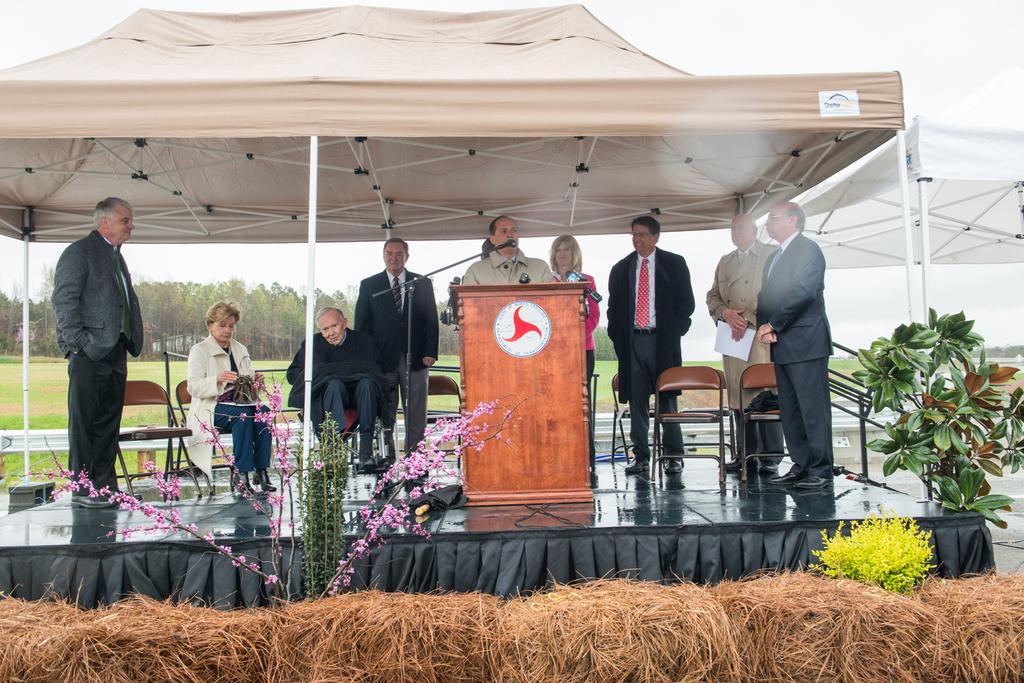In one or two sentences, can you explain what this image depicts? In this picture we can see plants, dried grass, tents, two people sitting on chairs and some people are standing on stage and a man standing at the podium and in front of him we can see mics and in the background we can see the grass, trees and the sky. 